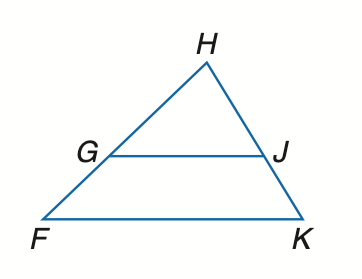Answer the mathemtical geometry problem and directly provide the correct option letter.
Question: Find x so that G J \parallel F K. H J = x - 5, J K = 15, F G = 18, H G = x - 4.
Choices: A: 10 B: 12 C: 15 D: 18 A 